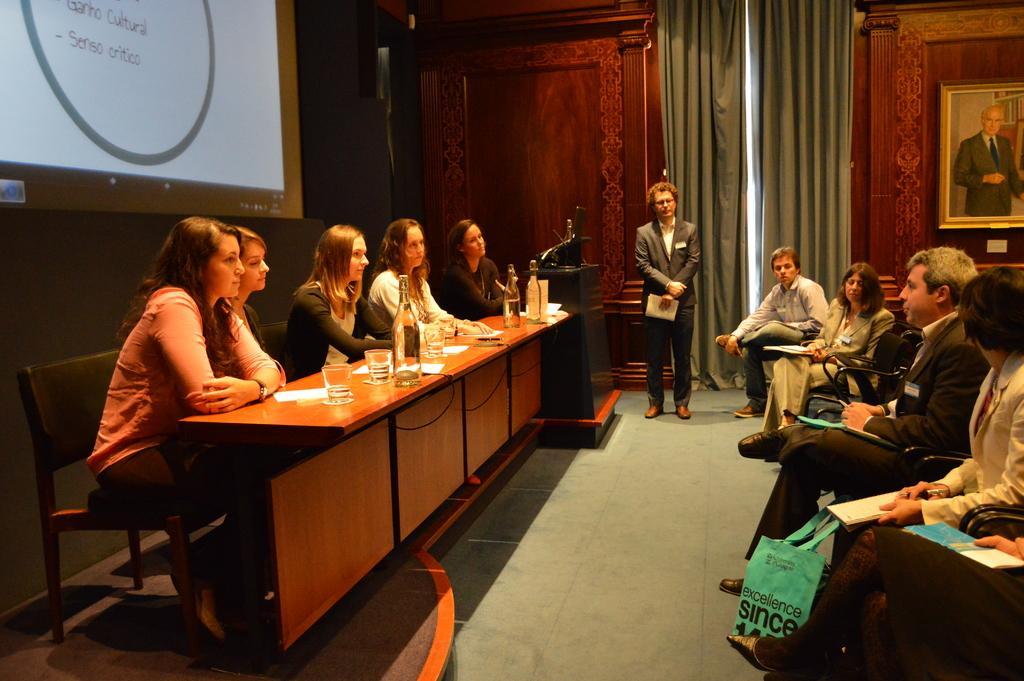In one or two sentences, can you explain what this image depicts? there are many people sitting in a chair with a table in front of them a person is standing near to them 